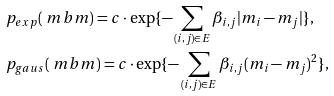<formula> <loc_0><loc_0><loc_500><loc_500>& { p } _ { e x p } ( \ m b m ) = c \cdot \exp \{ - \sum _ { ( i , j ) \in E } \beta _ { i , j } | m _ { i } - m _ { j } | \} , \\ & { p } _ { g a u s } ( \ m b m ) = c \cdot \exp \{ - \sum _ { ( i , j ) \in E } \beta _ { i , j } ( m _ { i } - m _ { j } ) ^ { 2 } \} ,</formula> 